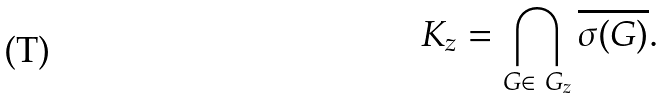Convert formula to latex. <formula><loc_0><loc_0><loc_500><loc_500>K _ { z } = \bigcap _ { G \in \ G _ { z } } \overline { \sigma ( G ) } .</formula> 